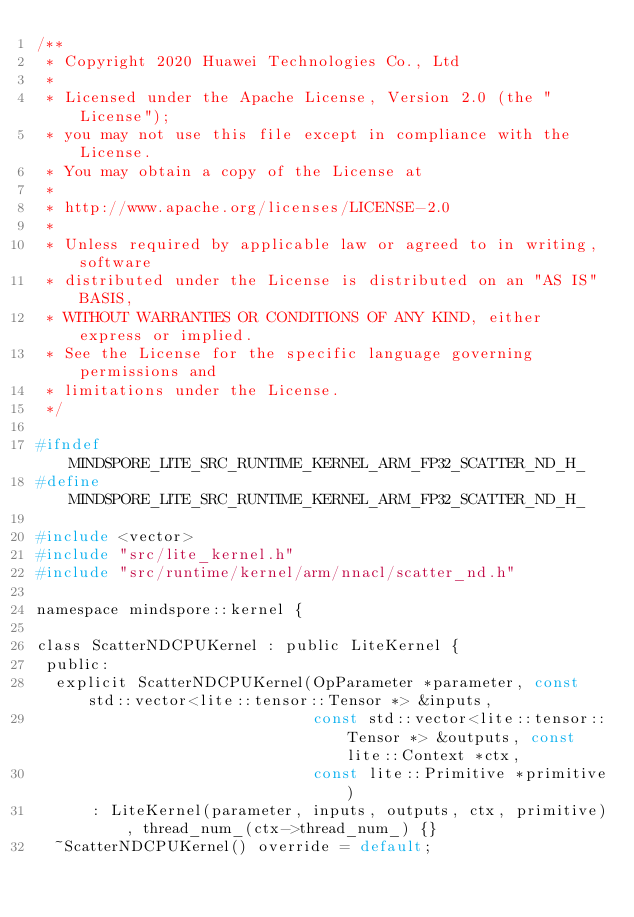Convert code to text. <code><loc_0><loc_0><loc_500><loc_500><_C_>/**
 * Copyright 2020 Huawei Technologies Co., Ltd
 *
 * Licensed under the Apache License, Version 2.0 (the "License");
 * you may not use this file except in compliance with the License.
 * You may obtain a copy of the License at
 *
 * http://www.apache.org/licenses/LICENSE-2.0
 *
 * Unless required by applicable law or agreed to in writing, software
 * distributed under the License is distributed on an "AS IS" BASIS,
 * WITHOUT WARRANTIES OR CONDITIONS OF ANY KIND, either express or implied.
 * See the License for the specific language governing permissions and
 * limitations under the License.
 */

#ifndef MINDSPORE_LITE_SRC_RUNTIME_KERNEL_ARM_FP32_SCATTER_ND_H_
#define MINDSPORE_LITE_SRC_RUNTIME_KERNEL_ARM_FP32_SCATTER_ND_H_

#include <vector>
#include "src/lite_kernel.h"
#include "src/runtime/kernel/arm/nnacl/scatter_nd.h"

namespace mindspore::kernel {

class ScatterNDCPUKernel : public LiteKernel {
 public:
  explicit ScatterNDCPUKernel(OpParameter *parameter, const std::vector<lite::tensor::Tensor *> &inputs,
                              const std::vector<lite::tensor::Tensor *> &outputs, const lite::Context *ctx,
                              const lite::Primitive *primitive)
      : LiteKernel(parameter, inputs, outputs, ctx, primitive), thread_num_(ctx->thread_num_) {}
  ~ScatterNDCPUKernel() override = default;
</code> 